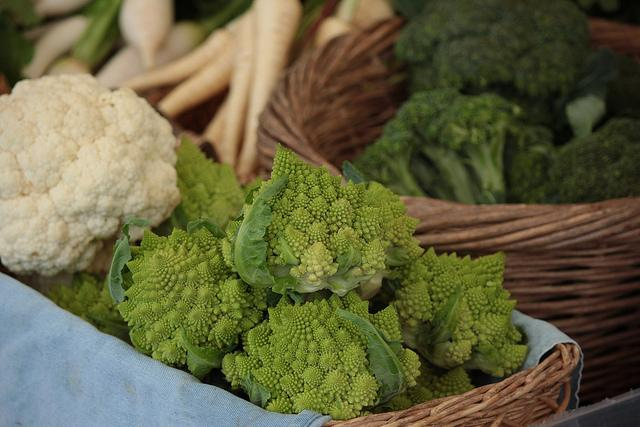What is the more realistic setting for these baskets of food items?

Choices:
A) home
B) lemonade stand
C) farmer's market
D) grocery farmer's market 